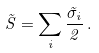<formula> <loc_0><loc_0><loc_500><loc_500>\vec { S } = \sum _ { i } { \frac { \vec { \sigma } _ { i } } { 2 } } \, .</formula> 